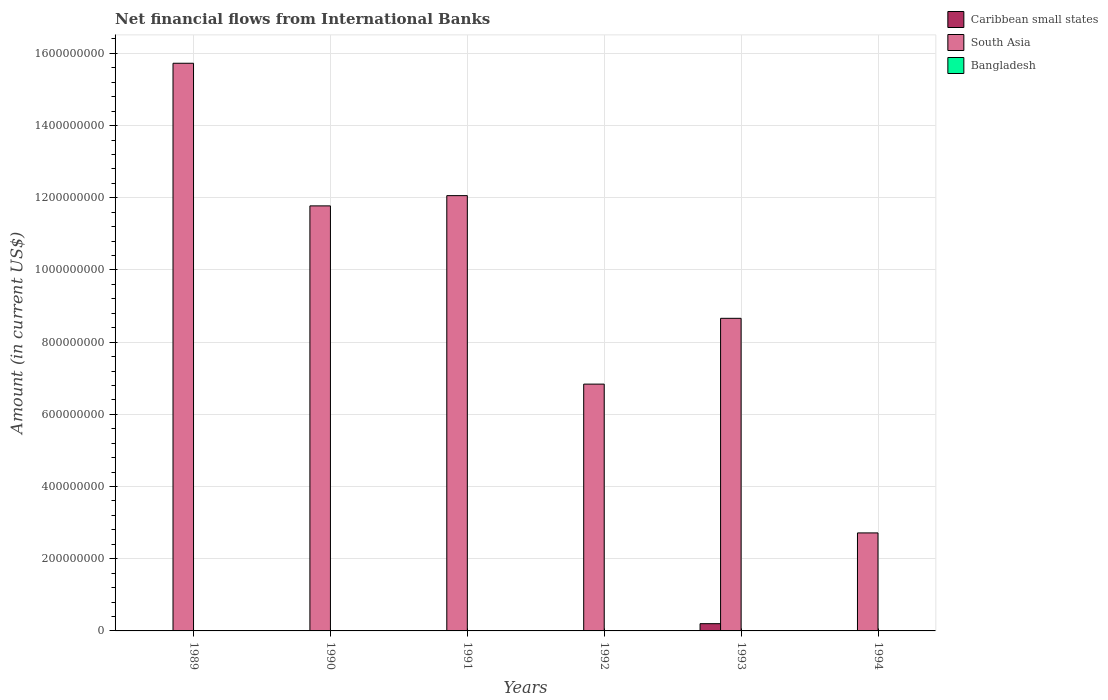Are the number of bars on each tick of the X-axis equal?
Make the answer very short. No. How many bars are there on the 5th tick from the right?
Your response must be concise. 1. In how many cases, is the number of bars for a given year not equal to the number of legend labels?
Your answer should be compact. 6. What is the net financial aid flows in South Asia in 1990?
Provide a succinct answer. 1.18e+09. Across all years, what is the maximum net financial aid flows in South Asia?
Your response must be concise. 1.57e+09. What is the total net financial aid flows in Caribbean small states in the graph?
Your response must be concise. 2.01e+07. What is the difference between the net financial aid flows in South Asia in 1989 and that in 1994?
Ensure brevity in your answer.  1.30e+09. What is the difference between the net financial aid flows in South Asia in 1992 and the net financial aid flows in Bangladesh in 1989?
Provide a short and direct response. 6.84e+08. What is the average net financial aid flows in Caribbean small states per year?
Your answer should be very brief. 3.35e+06. In the year 1993, what is the difference between the net financial aid flows in South Asia and net financial aid flows in Caribbean small states?
Provide a short and direct response. 8.46e+08. What is the ratio of the net financial aid flows in South Asia in 1989 to that in 1990?
Your response must be concise. 1.34. What is the difference between the highest and the second highest net financial aid flows in South Asia?
Offer a very short reply. 3.67e+08. What is the difference between the highest and the lowest net financial aid flows in South Asia?
Provide a short and direct response. 1.30e+09. Is the sum of the net financial aid flows in South Asia in 1992 and 1993 greater than the maximum net financial aid flows in Bangladesh across all years?
Keep it short and to the point. Yes. Is it the case that in every year, the sum of the net financial aid flows in South Asia and net financial aid flows in Bangladesh is greater than the net financial aid flows in Caribbean small states?
Provide a succinct answer. Yes. How many bars are there?
Provide a succinct answer. 7. What is the difference between two consecutive major ticks on the Y-axis?
Make the answer very short. 2.00e+08. Are the values on the major ticks of Y-axis written in scientific E-notation?
Your answer should be very brief. No. Does the graph contain grids?
Offer a terse response. Yes. Where does the legend appear in the graph?
Offer a very short reply. Top right. How are the legend labels stacked?
Your answer should be compact. Vertical. What is the title of the graph?
Offer a terse response. Net financial flows from International Banks. Does "Argentina" appear as one of the legend labels in the graph?
Keep it short and to the point. No. What is the label or title of the X-axis?
Make the answer very short. Years. What is the label or title of the Y-axis?
Your response must be concise. Amount (in current US$). What is the Amount (in current US$) of South Asia in 1989?
Your answer should be compact. 1.57e+09. What is the Amount (in current US$) of Bangladesh in 1989?
Keep it short and to the point. 0. What is the Amount (in current US$) in South Asia in 1990?
Give a very brief answer. 1.18e+09. What is the Amount (in current US$) of Bangladesh in 1990?
Your answer should be compact. 0. What is the Amount (in current US$) of South Asia in 1991?
Give a very brief answer. 1.21e+09. What is the Amount (in current US$) of Bangladesh in 1991?
Your response must be concise. 0. What is the Amount (in current US$) in South Asia in 1992?
Offer a very short reply. 6.84e+08. What is the Amount (in current US$) of Caribbean small states in 1993?
Keep it short and to the point. 2.01e+07. What is the Amount (in current US$) in South Asia in 1993?
Provide a succinct answer. 8.66e+08. What is the Amount (in current US$) of Caribbean small states in 1994?
Provide a short and direct response. 0. What is the Amount (in current US$) in South Asia in 1994?
Provide a succinct answer. 2.72e+08. What is the Amount (in current US$) of Bangladesh in 1994?
Give a very brief answer. 0. Across all years, what is the maximum Amount (in current US$) of Caribbean small states?
Make the answer very short. 2.01e+07. Across all years, what is the maximum Amount (in current US$) of South Asia?
Keep it short and to the point. 1.57e+09. Across all years, what is the minimum Amount (in current US$) of South Asia?
Offer a very short reply. 2.72e+08. What is the total Amount (in current US$) in Caribbean small states in the graph?
Offer a terse response. 2.01e+07. What is the total Amount (in current US$) of South Asia in the graph?
Offer a terse response. 5.78e+09. What is the difference between the Amount (in current US$) of South Asia in 1989 and that in 1990?
Your response must be concise. 3.95e+08. What is the difference between the Amount (in current US$) of South Asia in 1989 and that in 1991?
Offer a terse response. 3.67e+08. What is the difference between the Amount (in current US$) in South Asia in 1989 and that in 1992?
Give a very brief answer. 8.89e+08. What is the difference between the Amount (in current US$) in South Asia in 1989 and that in 1993?
Offer a terse response. 7.07e+08. What is the difference between the Amount (in current US$) in South Asia in 1989 and that in 1994?
Offer a terse response. 1.30e+09. What is the difference between the Amount (in current US$) of South Asia in 1990 and that in 1991?
Ensure brevity in your answer.  -2.84e+07. What is the difference between the Amount (in current US$) in South Asia in 1990 and that in 1992?
Keep it short and to the point. 4.94e+08. What is the difference between the Amount (in current US$) in South Asia in 1990 and that in 1993?
Your response must be concise. 3.12e+08. What is the difference between the Amount (in current US$) in South Asia in 1990 and that in 1994?
Make the answer very short. 9.06e+08. What is the difference between the Amount (in current US$) of South Asia in 1991 and that in 1992?
Provide a succinct answer. 5.22e+08. What is the difference between the Amount (in current US$) of South Asia in 1991 and that in 1993?
Keep it short and to the point. 3.40e+08. What is the difference between the Amount (in current US$) in South Asia in 1991 and that in 1994?
Make the answer very short. 9.34e+08. What is the difference between the Amount (in current US$) of South Asia in 1992 and that in 1993?
Offer a terse response. -1.82e+08. What is the difference between the Amount (in current US$) in South Asia in 1992 and that in 1994?
Offer a terse response. 4.12e+08. What is the difference between the Amount (in current US$) of South Asia in 1993 and that in 1994?
Offer a very short reply. 5.95e+08. What is the difference between the Amount (in current US$) in Caribbean small states in 1993 and the Amount (in current US$) in South Asia in 1994?
Keep it short and to the point. -2.51e+08. What is the average Amount (in current US$) in Caribbean small states per year?
Give a very brief answer. 3.35e+06. What is the average Amount (in current US$) of South Asia per year?
Keep it short and to the point. 9.63e+08. What is the average Amount (in current US$) of Bangladesh per year?
Make the answer very short. 0. In the year 1993, what is the difference between the Amount (in current US$) in Caribbean small states and Amount (in current US$) in South Asia?
Provide a succinct answer. -8.46e+08. What is the ratio of the Amount (in current US$) of South Asia in 1989 to that in 1990?
Your response must be concise. 1.34. What is the ratio of the Amount (in current US$) in South Asia in 1989 to that in 1991?
Offer a very short reply. 1.3. What is the ratio of the Amount (in current US$) in South Asia in 1989 to that in 1992?
Offer a terse response. 2.3. What is the ratio of the Amount (in current US$) of South Asia in 1989 to that in 1993?
Offer a terse response. 1.82. What is the ratio of the Amount (in current US$) of South Asia in 1989 to that in 1994?
Keep it short and to the point. 5.79. What is the ratio of the Amount (in current US$) in South Asia in 1990 to that in 1991?
Offer a very short reply. 0.98. What is the ratio of the Amount (in current US$) in South Asia in 1990 to that in 1992?
Offer a very short reply. 1.72. What is the ratio of the Amount (in current US$) in South Asia in 1990 to that in 1993?
Give a very brief answer. 1.36. What is the ratio of the Amount (in current US$) of South Asia in 1990 to that in 1994?
Your answer should be very brief. 4.34. What is the ratio of the Amount (in current US$) of South Asia in 1991 to that in 1992?
Provide a succinct answer. 1.76. What is the ratio of the Amount (in current US$) of South Asia in 1991 to that in 1993?
Your response must be concise. 1.39. What is the ratio of the Amount (in current US$) in South Asia in 1991 to that in 1994?
Ensure brevity in your answer.  4.44. What is the ratio of the Amount (in current US$) of South Asia in 1992 to that in 1993?
Ensure brevity in your answer.  0.79. What is the ratio of the Amount (in current US$) of South Asia in 1992 to that in 1994?
Your response must be concise. 2.52. What is the ratio of the Amount (in current US$) of South Asia in 1993 to that in 1994?
Provide a succinct answer. 3.19. What is the difference between the highest and the second highest Amount (in current US$) in South Asia?
Offer a very short reply. 3.67e+08. What is the difference between the highest and the lowest Amount (in current US$) in Caribbean small states?
Your response must be concise. 2.01e+07. What is the difference between the highest and the lowest Amount (in current US$) in South Asia?
Keep it short and to the point. 1.30e+09. 